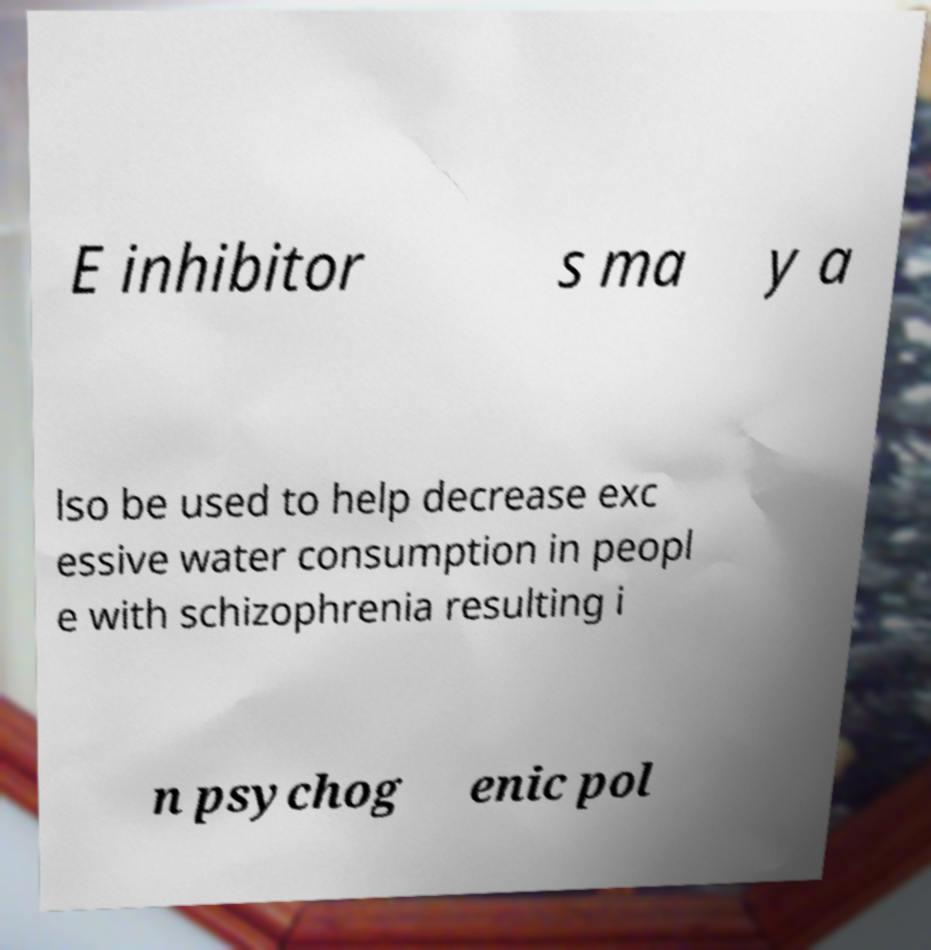Could you assist in decoding the text presented in this image and type it out clearly? E inhibitor s ma y a lso be used to help decrease exc essive water consumption in peopl e with schizophrenia resulting i n psychog enic pol 